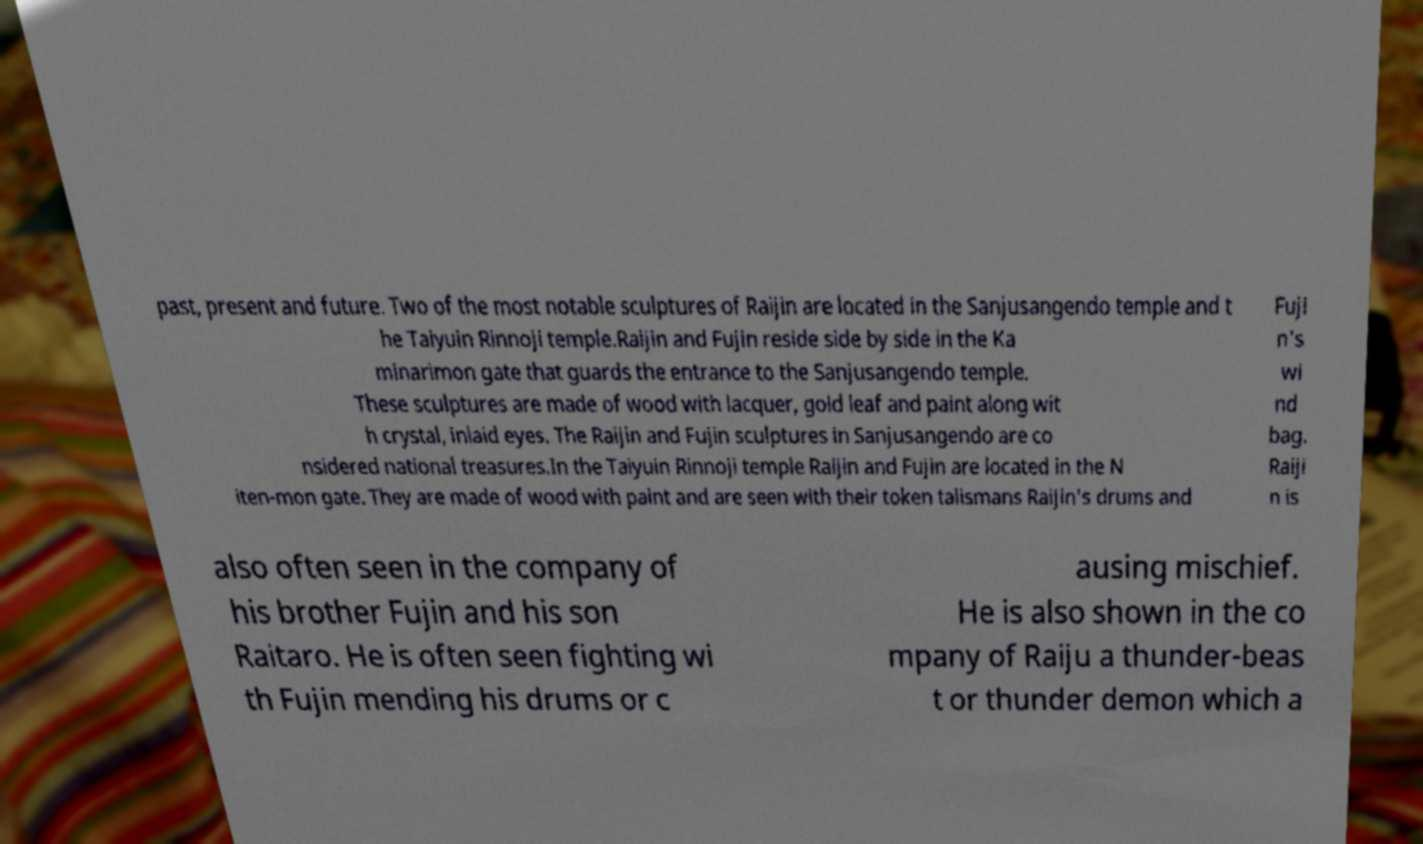Can you accurately transcribe the text from the provided image for me? past, present and future. Two of the most notable sculptures of Raijin are located in the Sanjusangendo temple and t he Taiyuin Rinnoji temple.Raijin and Fujin reside side by side in the Ka minarimon gate that guards the entrance to the Sanjusangendo temple. These sculptures are made of wood with lacquer, gold leaf and paint along wit h crystal, inlaid eyes. The Raijin and Fujin sculptures in Sanjusangendo are co nsidered national treasures.In the Taiyuin Rinnoji temple Raijin and Fujin are located in the N iten-mon gate. They are made of wood with paint and are seen with their token talismans Raijin's drums and Fuji n's wi nd bag. Raiji n is also often seen in the company of his brother Fujin and his son Raitaro. He is often seen fighting wi th Fujin mending his drums or c ausing mischief. He is also shown in the co mpany of Raiju a thunder-beas t or thunder demon which a 